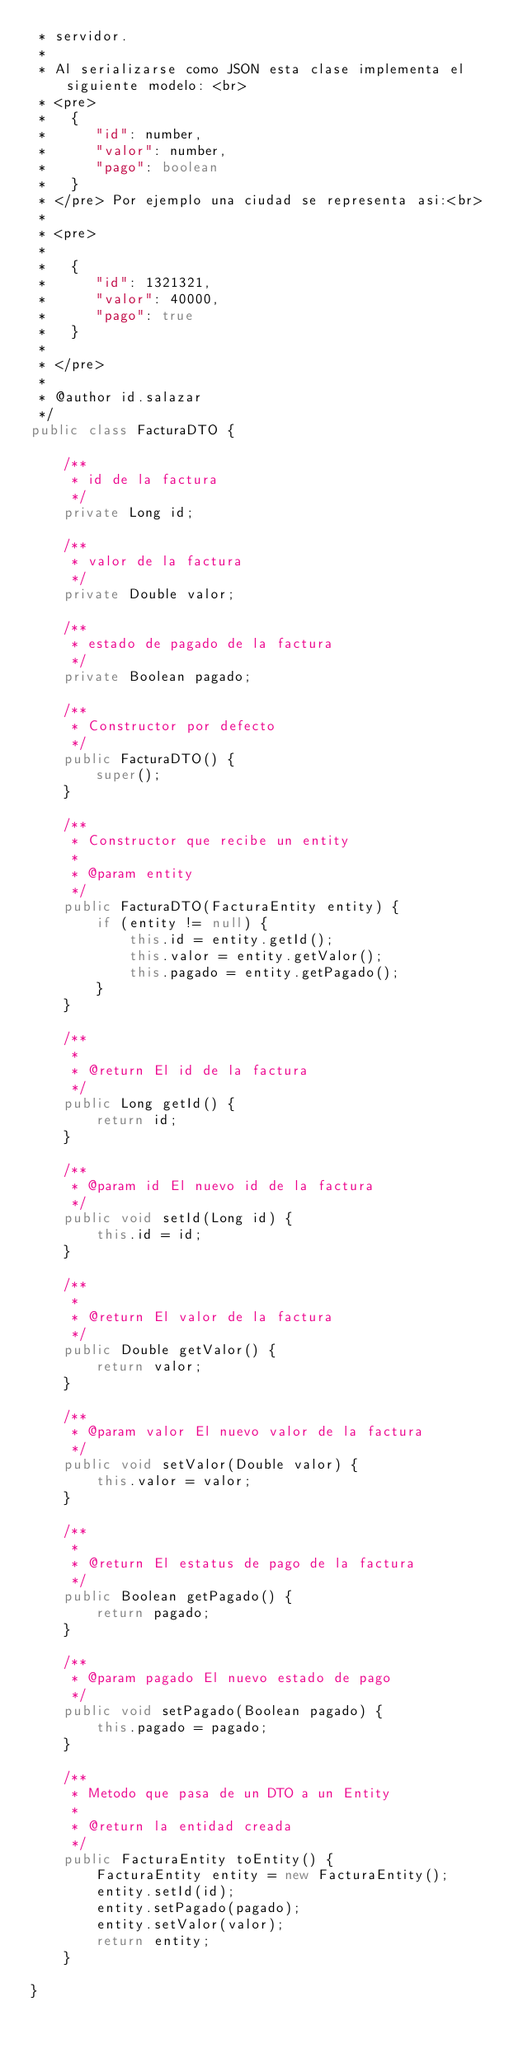<code> <loc_0><loc_0><loc_500><loc_500><_Java_> * servidor.
 *
 * Al serializarse como JSON esta clase implementa el siguiente modelo: <br>
 * <pre>
 *   {
 *      "id": number,
 *      "valor": number,
 *      "pago": boolean
 *   }
 * </pre> Por ejemplo una ciudad se representa asi:<br>
 *
 * <pre>
 *
 *   {
 *      "id": 1321321,
 *      "valor": 40000,
 *      "pago": true
 *   }
 *
 * </pre>
 *
 * @author id.salazar
 */
public class FacturaDTO {

    /**
     * id de la factura
     */
    private Long id;

    /**
     * valor de la factura
     */
    private Double valor;

    /**
     * estado de pagado de la factura
     */
    private Boolean pagado;

    /**
     * Constructor por defecto
     */
    public FacturaDTO() {
        super();
    }

    /**
     * Constructor que recibe un entity
     *
     * @param entity
     */
    public FacturaDTO(FacturaEntity entity) {
        if (entity != null) {
            this.id = entity.getId();
            this.valor = entity.getValor();
            this.pagado = entity.getPagado();
        }
    }

    /**
     *
     * @return El id de la factura
     */
    public Long getId() {
        return id;
    }

    /**
     * @param id El nuevo id de la factura
     */
    public void setId(Long id) {
        this.id = id;
    }

    /**
     *
     * @return El valor de la factura
     */
    public Double getValor() {
        return valor;
    }

    /**
     * @param valor El nuevo valor de la factura
     */
    public void setValor(Double valor) {
        this.valor = valor;
    }

    /**
     *
     * @return El estatus de pago de la factura
     */
    public Boolean getPagado() {
        return pagado;
    }

    /**
     * @param pagado El nuevo estado de pago
     */
    public void setPagado(Boolean pagado) {
        this.pagado = pagado;
    }

    /**
     * Metodo que pasa de un DTO a un Entity
     *
     * @return la entidad creada
     */
    public FacturaEntity toEntity() {
        FacturaEntity entity = new FacturaEntity();
        entity.setId(id);
        entity.setPagado(pagado);
        entity.setValor(valor);
        return entity;
    }

}
</code> 